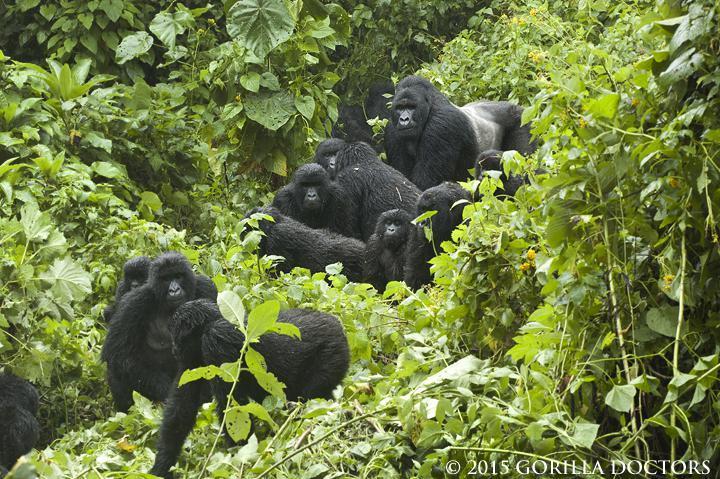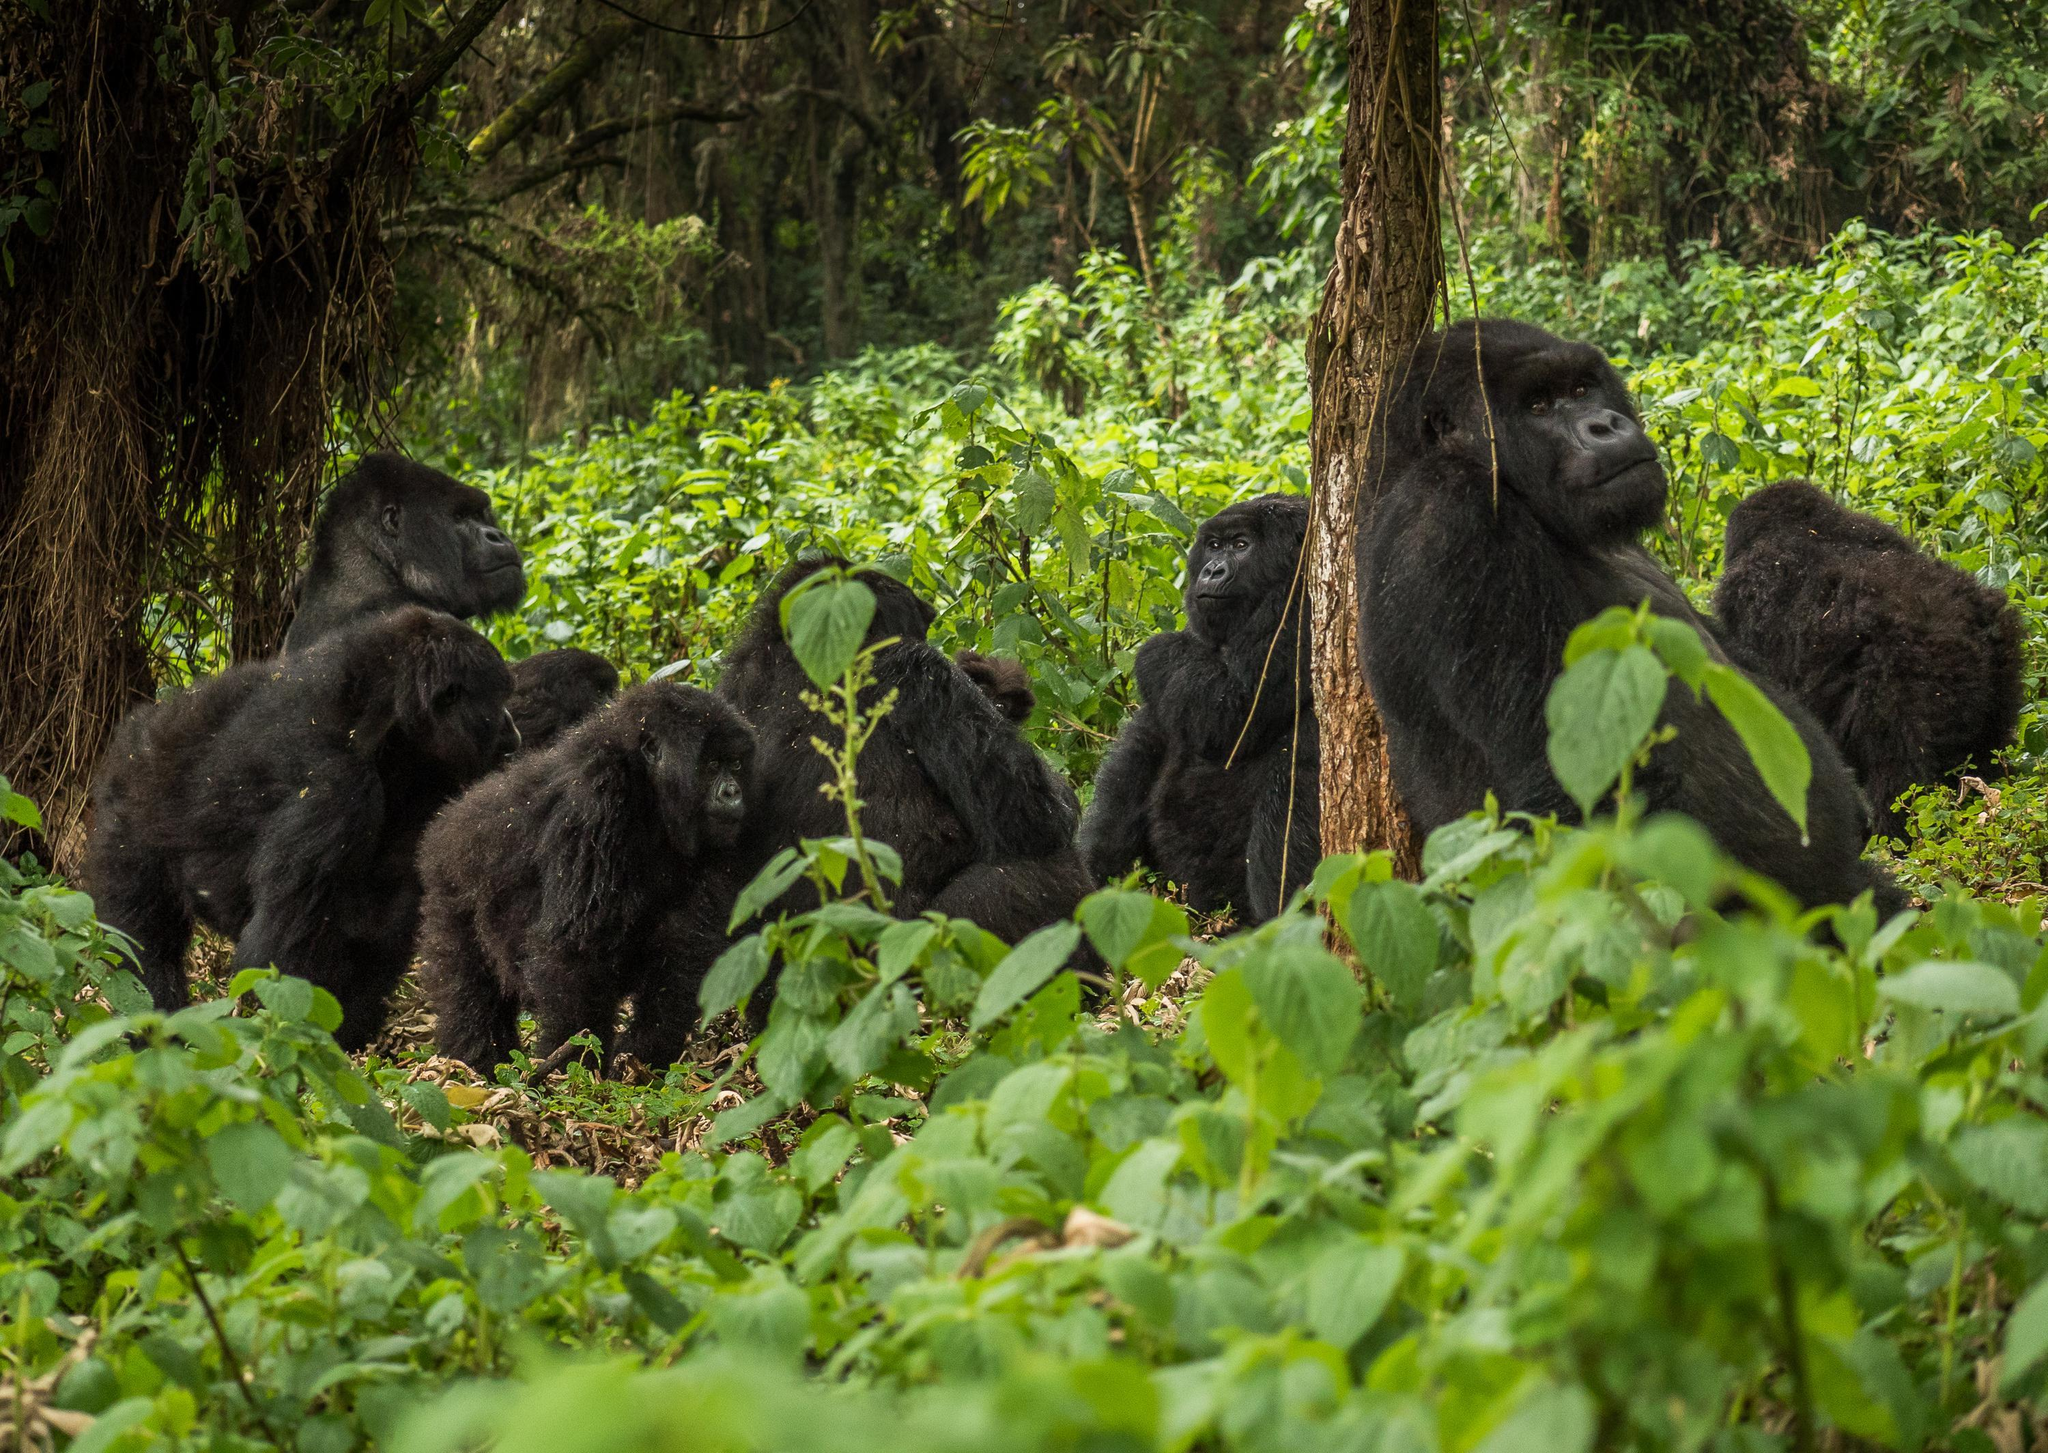The first image is the image on the left, the second image is the image on the right. Analyze the images presented: Is the assertion "There are no more than two animals in a grassy area in the image on the right." valid? Answer yes or no. No. 